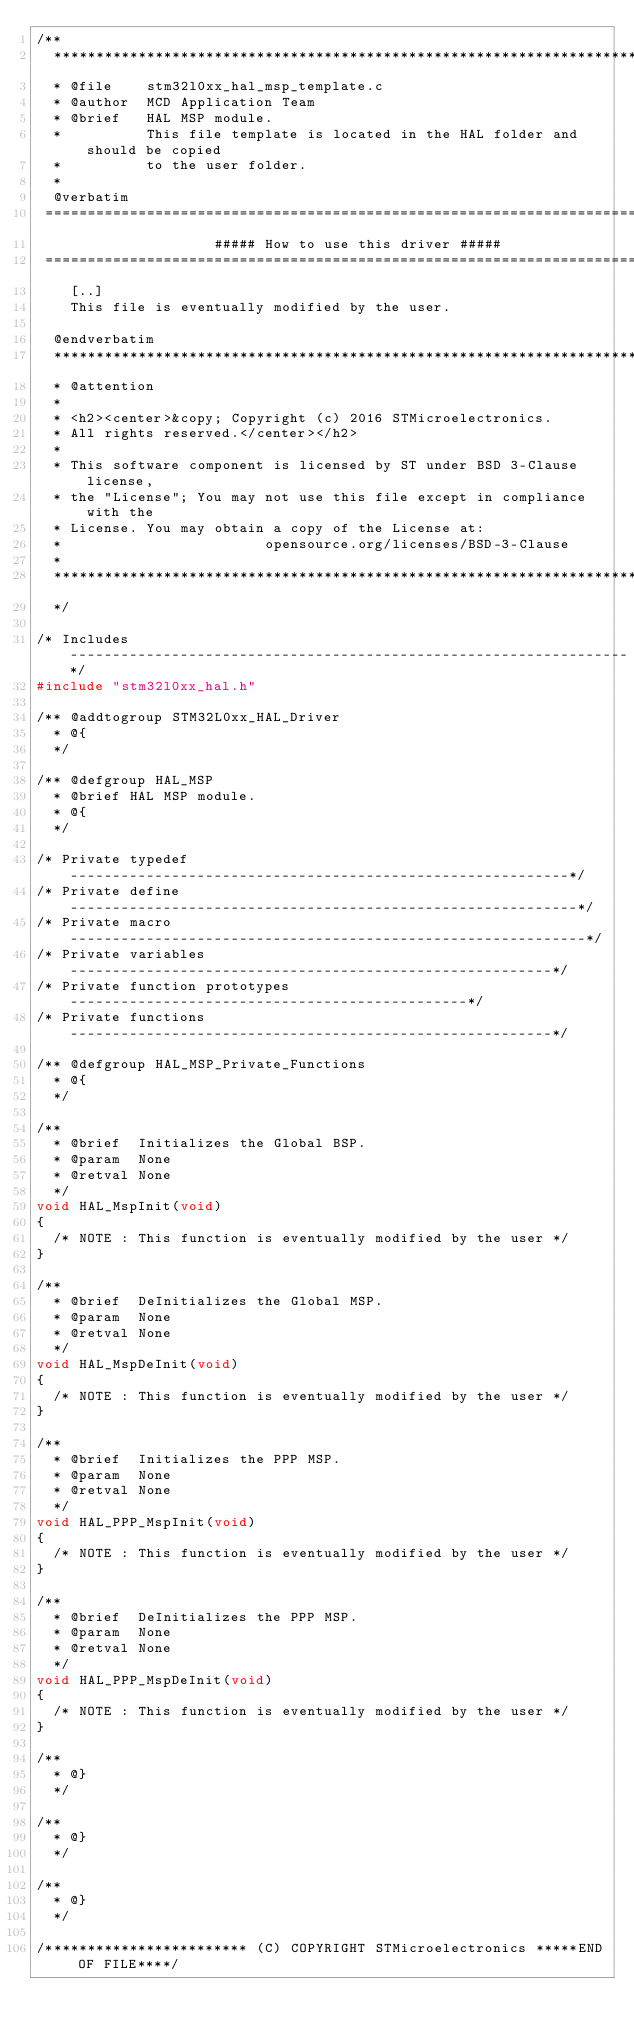<code> <loc_0><loc_0><loc_500><loc_500><_C_>/**
  ******************************************************************************
  * @file    stm32l0xx_hal_msp_template.c
  * @author  MCD Application Team
  * @brief   HAL MSP module.
  *          This file template is located in the HAL folder and should be copied 
  *          to the user folder.
  *         
  @verbatim
 ===============================================================================
                     ##### How to use this driver #####
 ===============================================================================
    [..]
    This file is eventually modified by the user.

  @endverbatim
  ******************************************************************************
  * @attention
  *
  * <h2><center>&copy; Copyright (c) 2016 STMicroelectronics. 
  * All rights reserved.</center></h2>
  *
  * This software component is licensed by ST under BSD 3-Clause license,
  * the "License"; You may not use this file except in compliance with the 
  * License. You may obtain a copy of the License at:
  *                        opensource.org/licenses/BSD-3-Clause
  *
  ******************************************************************************  
  */ 

/* Includes ------------------------------------------------------------------*/
#include "stm32l0xx_hal.h"

/** @addtogroup STM32L0xx_HAL_Driver
  * @{
  */

/** @defgroup HAL_MSP
  * @brief HAL MSP module.
  * @{
  */

/* Private typedef -----------------------------------------------------------*/
/* Private define ------------------------------------------------------------*/
/* Private macro -------------------------------------------------------------*/
/* Private variables ---------------------------------------------------------*/
/* Private function prototypes -----------------------------------------------*/
/* Private functions ---------------------------------------------------------*/

/** @defgroup HAL_MSP_Private_Functions
  * @{
  */

/**
  * @brief  Initializes the Global BSP.
  * @param  None
  * @retval None
  */
void HAL_MspInit(void)
{
  /* NOTE : This function is eventually modified by the user */ 
}

/**
  * @brief  DeInitializes the Global MSP.
  * @param  None  
  * @retval None
  */
void HAL_MspDeInit(void)
{
  /* NOTE : This function is eventually modified by the user */
}

/**
  * @brief  Initializes the PPP MSP.
  * @param  None
  * @retval None
  */
void HAL_PPP_MspInit(void)
{
  /* NOTE : This function is eventually modified by the user */ 
}

/**
  * @brief  DeInitializes the PPP MSP.
  * @param  None  
  * @retval None
  */
void HAL_PPP_MspDeInit(void)
{
  /* NOTE : This function is eventually modified by the user */
}

/**
  * @}
  */

/**
  * @}
  */

/**
  * @}
  */

/************************ (C) COPYRIGHT STMicroelectronics *****END OF FILE****/

</code> 